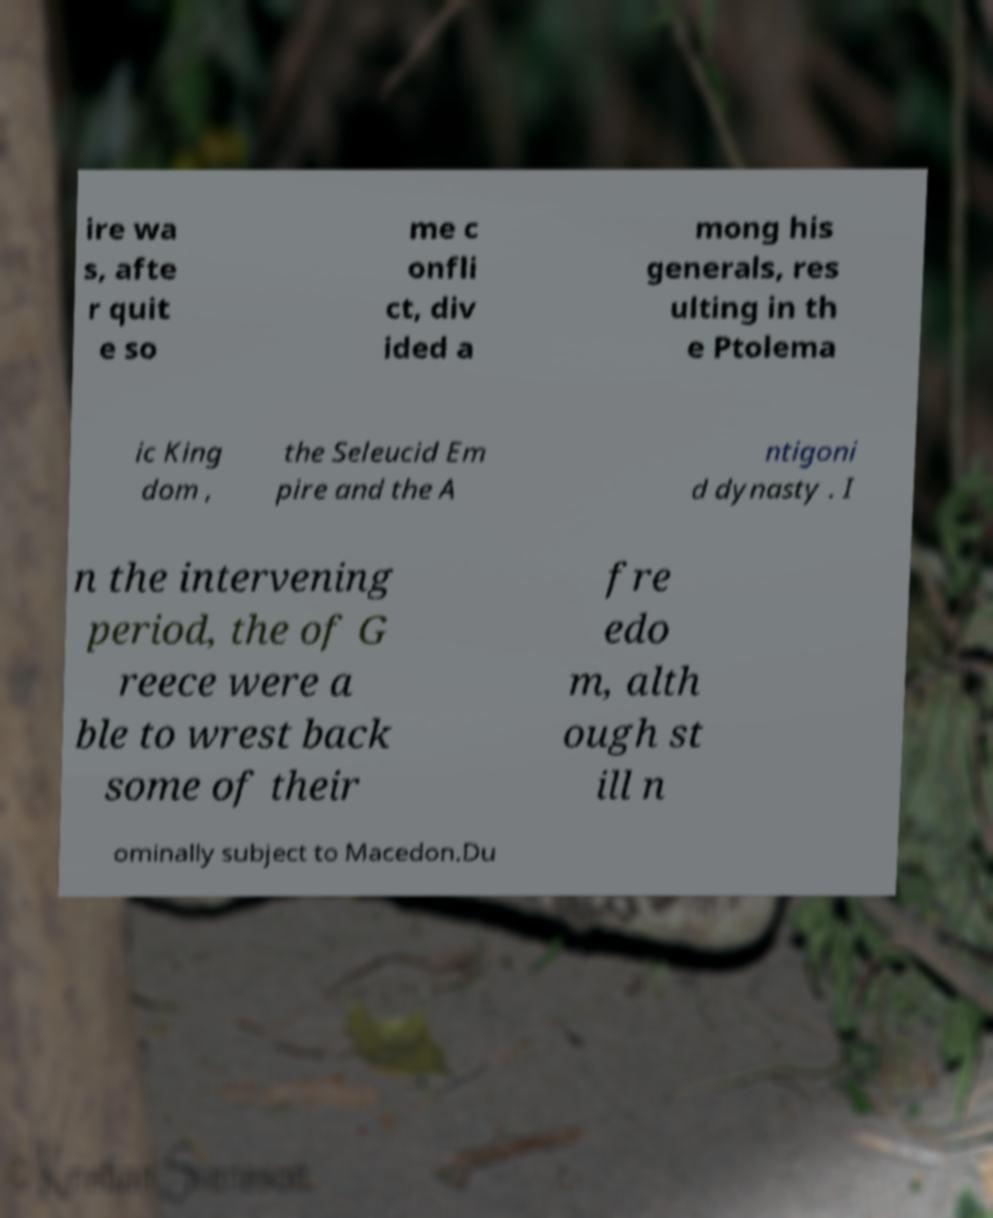Can you accurately transcribe the text from the provided image for me? ire wa s, afte r quit e so me c onfli ct, div ided a mong his generals, res ulting in th e Ptolema ic King dom , the Seleucid Em pire and the A ntigoni d dynasty . I n the intervening period, the of G reece were a ble to wrest back some of their fre edo m, alth ough st ill n ominally subject to Macedon.Du 